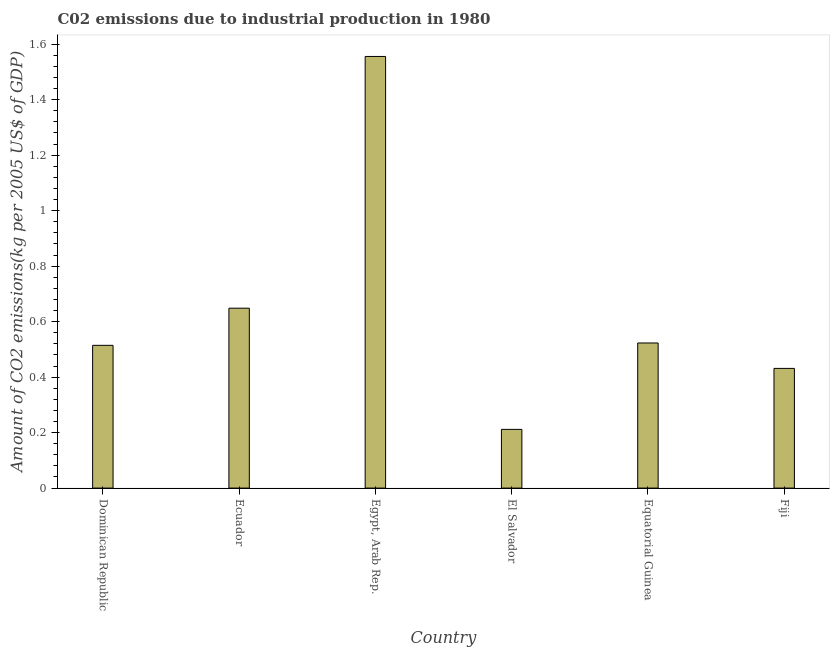What is the title of the graph?
Offer a very short reply. C02 emissions due to industrial production in 1980. What is the label or title of the Y-axis?
Provide a short and direct response. Amount of CO2 emissions(kg per 2005 US$ of GDP). What is the amount of co2 emissions in Ecuador?
Your response must be concise. 0.65. Across all countries, what is the maximum amount of co2 emissions?
Your response must be concise. 1.56. Across all countries, what is the minimum amount of co2 emissions?
Your response must be concise. 0.21. In which country was the amount of co2 emissions maximum?
Ensure brevity in your answer.  Egypt, Arab Rep. In which country was the amount of co2 emissions minimum?
Your answer should be very brief. El Salvador. What is the sum of the amount of co2 emissions?
Offer a very short reply. 3.88. What is the difference between the amount of co2 emissions in Egypt, Arab Rep. and El Salvador?
Ensure brevity in your answer.  1.34. What is the average amount of co2 emissions per country?
Your answer should be compact. 0.65. What is the median amount of co2 emissions?
Give a very brief answer. 0.52. What is the ratio of the amount of co2 emissions in Dominican Republic to that in El Salvador?
Ensure brevity in your answer.  2.43. Is the amount of co2 emissions in Dominican Republic less than that in El Salvador?
Give a very brief answer. No. Is the difference between the amount of co2 emissions in Ecuador and Egypt, Arab Rep. greater than the difference between any two countries?
Offer a very short reply. No. What is the difference between the highest and the second highest amount of co2 emissions?
Your answer should be compact. 0.91. Is the sum of the amount of co2 emissions in Ecuador and El Salvador greater than the maximum amount of co2 emissions across all countries?
Make the answer very short. No. What is the difference between the highest and the lowest amount of co2 emissions?
Offer a very short reply. 1.34. In how many countries, is the amount of co2 emissions greater than the average amount of co2 emissions taken over all countries?
Keep it short and to the point. 2. Are all the bars in the graph horizontal?
Make the answer very short. No. How many countries are there in the graph?
Provide a succinct answer. 6. What is the difference between two consecutive major ticks on the Y-axis?
Ensure brevity in your answer.  0.2. Are the values on the major ticks of Y-axis written in scientific E-notation?
Your answer should be compact. No. What is the Amount of CO2 emissions(kg per 2005 US$ of GDP) in Dominican Republic?
Make the answer very short. 0.51. What is the Amount of CO2 emissions(kg per 2005 US$ of GDP) in Ecuador?
Offer a terse response. 0.65. What is the Amount of CO2 emissions(kg per 2005 US$ of GDP) of Egypt, Arab Rep.?
Ensure brevity in your answer.  1.56. What is the Amount of CO2 emissions(kg per 2005 US$ of GDP) of El Salvador?
Keep it short and to the point. 0.21. What is the Amount of CO2 emissions(kg per 2005 US$ of GDP) in Equatorial Guinea?
Keep it short and to the point. 0.52. What is the Amount of CO2 emissions(kg per 2005 US$ of GDP) in Fiji?
Offer a very short reply. 0.43. What is the difference between the Amount of CO2 emissions(kg per 2005 US$ of GDP) in Dominican Republic and Ecuador?
Give a very brief answer. -0.13. What is the difference between the Amount of CO2 emissions(kg per 2005 US$ of GDP) in Dominican Republic and Egypt, Arab Rep.?
Provide a succinct answer. -1.04. What is the difference between the Amount of CO2 emissions(kg per 2005 US$ of GDP) in Dominican Republic and El Salvador?
Provide a short and direct response. 0.3. What is the difference between the Amount of CO2 emissions(kg per 2005 US$ of GDP) in Dominican Republic and Equatorial Guinea?
Your answer should be compact. -0.01. What is the difference between the Amount of CO2 emissions(kg per 2005 US$ of GDP) in Dominican Republic and Fiji?
Provide a short and direct response. 0.08. What is the difference between the Amount of CO2 emissions(kg per 2005 US$ of GDP) in Ecuador and Egypt, Arab Rep.?
Provide a succinct answer. -0.91. What is the difference between the Amount of CO2 emissions(kg per 2005 US$ of GDP) in Ecuador and El Salvador?
Provide a short and direct response. 0.44. What is the difference between the Amount of CO2 emissions(kg per 2005 US$ of GDP) in Ecuador and Equatorial Guinea?
Offer a very short reply. 0.13. What is the difference between the Amount of CO2 emissions(kg per 2005 US$ of GDP) in Ecuador and Fiji?
Make the answer very short. 0.22. What is the difference between the Amount of CO2 emissions(kg per 2005 US$ of GDP) in Egypt, Arab Rep. and El Salvador?
Keep it short and to the point. 1.34. What is the difference between the Amount of CO2 emissions(kg per 2005 US$ of GDP) in Egypt, Arab Rep. and Equatorial Guinea?
Ensure brevity in your answer.  1.03. What is the difference between the Amount of CO2 emissions(kg per 2005 US$ of GDP) in Egypt, Arab Rep. and Fiji?
Your answer should be compact. 1.12. What is the difference between the Amount of CO2 emissions(kg per 2005 US$ of GDP) in El Salvador and Equatorial Guinea?
Give a very brief answer. -0.31. What is the difference between the Amount of CO2 emissions(kg per 2005 US$ of GDP) in El Salvador and Fiji?
Make the answer very short. -0.22. What is the difference between the Amount of CO2 emissions(kg per 2005 US$ of GDP) in Equatorial Guinea and Fiji?
Your answer should be very brief. 0.09. What is the ratio of the Amount of CO2 emissions(kg per 2005 US$ of GDP) in Dominican Republic to that in Ecuador?
Keep it short and to the point. 0.79. What is the ratio of the Amount of CO2 emissions(kg per 2005 US$ of GDP) in Dominican Republic to that in Egypt, Arab Rep.?
Give a very brief answer. 0.33. What is the ratio of the Amount of CO2 emissions(kg per 2005 US$ of GDP) in Dominican Republic to that in El Salvador?
Provide a succinct answer. 2.43. What is the ratio of the Amount of CO2 emissions(kg per 2005 US$ of GDP) in Dominican Republic to that in Equatorial Guinea?
Keep it short and to the point. 0.98. What is the ratio of the Amount of CO2 emissions(kg per 2005 US$ of GDP) in Dominican Republic to that in Fiji?
Offer a very short reply. 1.19. What is the ratio of the Amount of CO2 emissions(kg per 2005 US$ of GDP) in Ecuador to that in Egypt, Arab Rep.?
Provide a succinct answer. 0.42. What is the ratio of the Amount of CO2 emissions(kg per 2005 US$ of GDP) in Ecuador to that in El Salvador?
Your answer should be very brief. 3.06. What is the ratio of the Amount of CO2 emissions(kg per 2005 US$ of GDP) in Ecuador to that in Equatorial Guinea?
Provide a short and direct response. 1.24. What is the ratio of the Amount of CO2 emissions(kg per 2005 US$ of GDP) in Ecuador to that in Fiji?
Your answer should be compact. 1.5. What is the ratio of the Amount of CO2 emissions(kg per 2005 US$ of GDP) in Egypt, Arab Rep. to that in El Salvador?
Keep it short and to the point. 7.35. What is the ratio of the Amount of CO2 emissions(kg per 2005 US$ of GDP) in Egypt, Arab Rep. to that in Equatorial Guinea?
Offer a terse response. 2.97. What is the ratio of the Amount of CO2 emissions(kg per 2005 US$ of GDP) in Egypt, Arab Rep. to that in Fiji?
Give a very brief answer. 3.61. What is the ratio of the Amount of CO2 emissions(kg per 2005 US$ of GDP) in El Salvador to that in Equatorial Guinea?
Your answer should be compact. 0.41. What is the ratio of the Amount of CO2 emissions(kg per 2005 US$ of GDP) in El Salvador to that in Fiji?
Your answer should be compact. 0.49. What is the ratio of the Amount of CO2 emissions(kg per 2005 US$ of GDP) in Equatorial Guinea to that in Fiji?
Give a very brief answer. 1.21. 